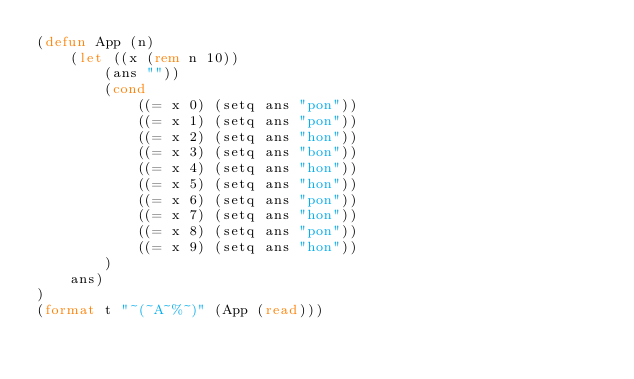Convert code to text. <code><loc_0><loc_0><loc_500><loc_500><_Lisp_>(defun App (n)
    (let ((x (rem n 10))
        (ans ""))
        (cond 
            ((= x 0) (setq ans "pon"))
            ((= x 1) (setq ans "pon"))
            ((= x 2) (setq ans "hon"))
            ((= x 3) (setq ans "bon"))
            ((= x 4) (setq ans "hon"))
            ((= x 5) (setq ans "hon"))
            ((= x 6) (setq ans "pon"))
            ((= x 7) (setq ans "hon"))
            ((= x 8) (setq ans "pon"))
            ((= x 9) (setq ans "hon"))
        )
    ans)
)
(format t "~(~A~%~)" (App (read)))</code> 